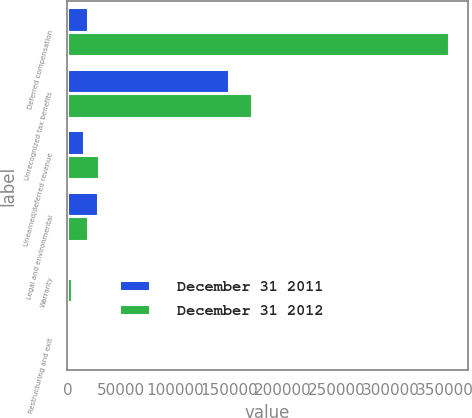<chart> <loc_0><loc_0><loc_500><loc_500><stacked_bar_chart><ecel><fcel>Deferred compensation<fcel>Unrecognized tax benefits<fcel>Unearned/deferred revenue<fcel>Legal and environmental<fcel>Warranty<fcel>Restructuring and exit<nl><fcel>December 31 2011<fcel>18910<fcel>149791<fcel>15474<fcel>28160<fcel>2690<fcel>96<nl><fcel>December 31 2012<fcel>353509<fcel>171551<fcel>29642<fcel>18910<fcel>4078<fcel>575<nl></chart> 